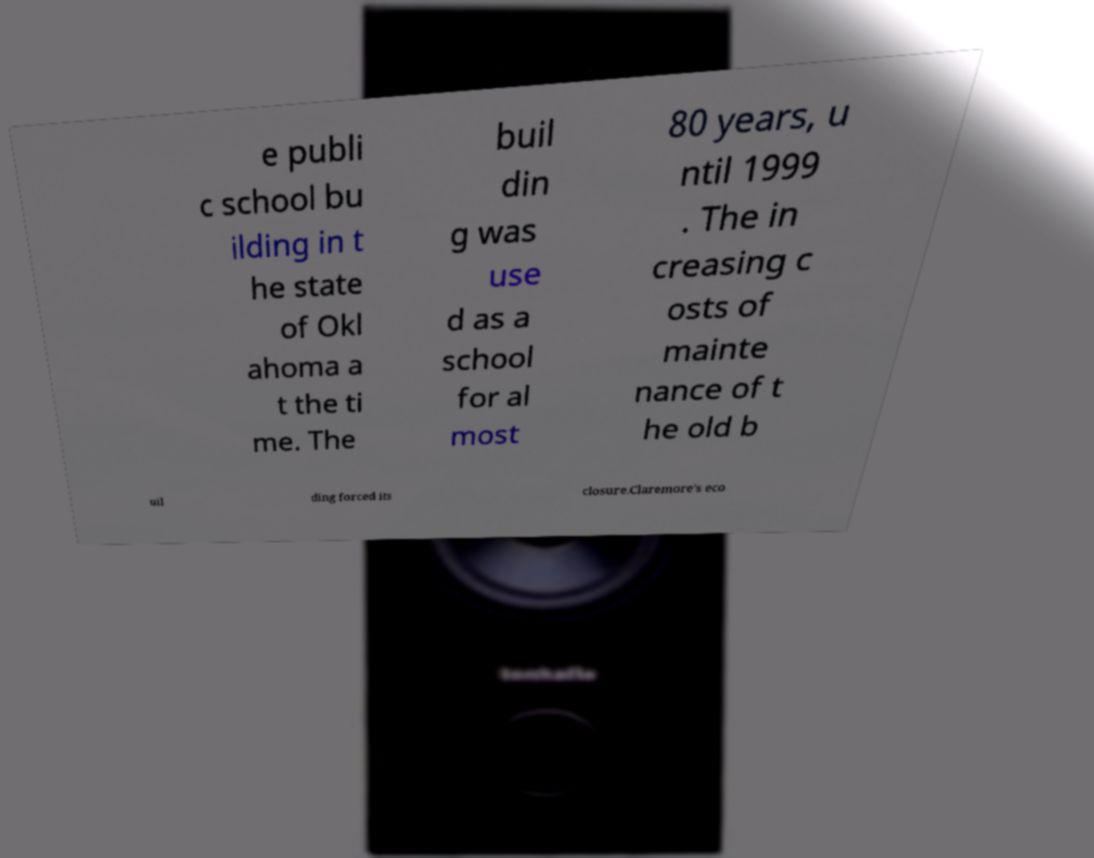Please identify and transcribe the text found in this image. e publi c school bu ilding in t he state of Okl ahoma a t the ti me. The buil din g was use d as a school for al most 80 years, u ntil 1999 . The in creasing c osts of mainte nance of t he old b uil ding forced its closure.Claremore's eco 